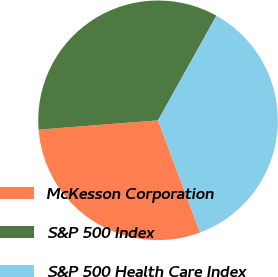<chart> <loc_0><loc_0><loc_500><loc_500><pie_chart><fcel>McKesson Corporation<fcel>S&P 500 Index<fcel>S&P 500 Health Care Index<nl><fcel>29.48%<fcel>34.34%<fcel>36.17%<nl></chart> 